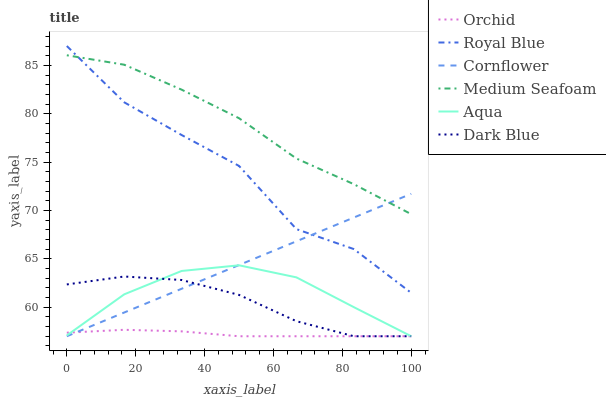Does Orchid have the minimum area under the curve?
Answer yes or no. Yes. Does Medium Seafoam have the maximum area under the curve?
Answer yes or no. Yes. Does Dark Blue have the minimum area under the curve?
Answer yes or no. No. Does Dark Blue have the maximum area under the curve?
Answer yes or no. No. Is Cornflower the smoothest?
Answer yes or no. Yes. Is Royal Blue the roughest?
Answer yes or no. Yes. Is Dark Blue the smoothest?
Answer yes or no. No. Is Dark Blue the roughest?
Answer yes or no. No. Does Cornflower have the lowest value?
Answer yes or no. Yes. Does Royal Blue have the lowest value?
Answer yes or no. No. Does Royal Blue have the highest value?
Answer yes or no. Yes. Does Dark Blue have the highest value?
Answer yes or no. No. Is Aqua less than Royal Blue?
Answer yes or no. Yes. Is Royal Blue greater than Aqua?
Answer yes or no. Yes. Does Aqua intersect Cornflower?
Answer yes or no. Yes. Is Aqua less than Cornflower?
Answer yes or no. No. Is Aqua greater than Cornflower?
Answer yes or no. No. Does Aqua intersect Royal Blue?
Answer yes or no. No. 